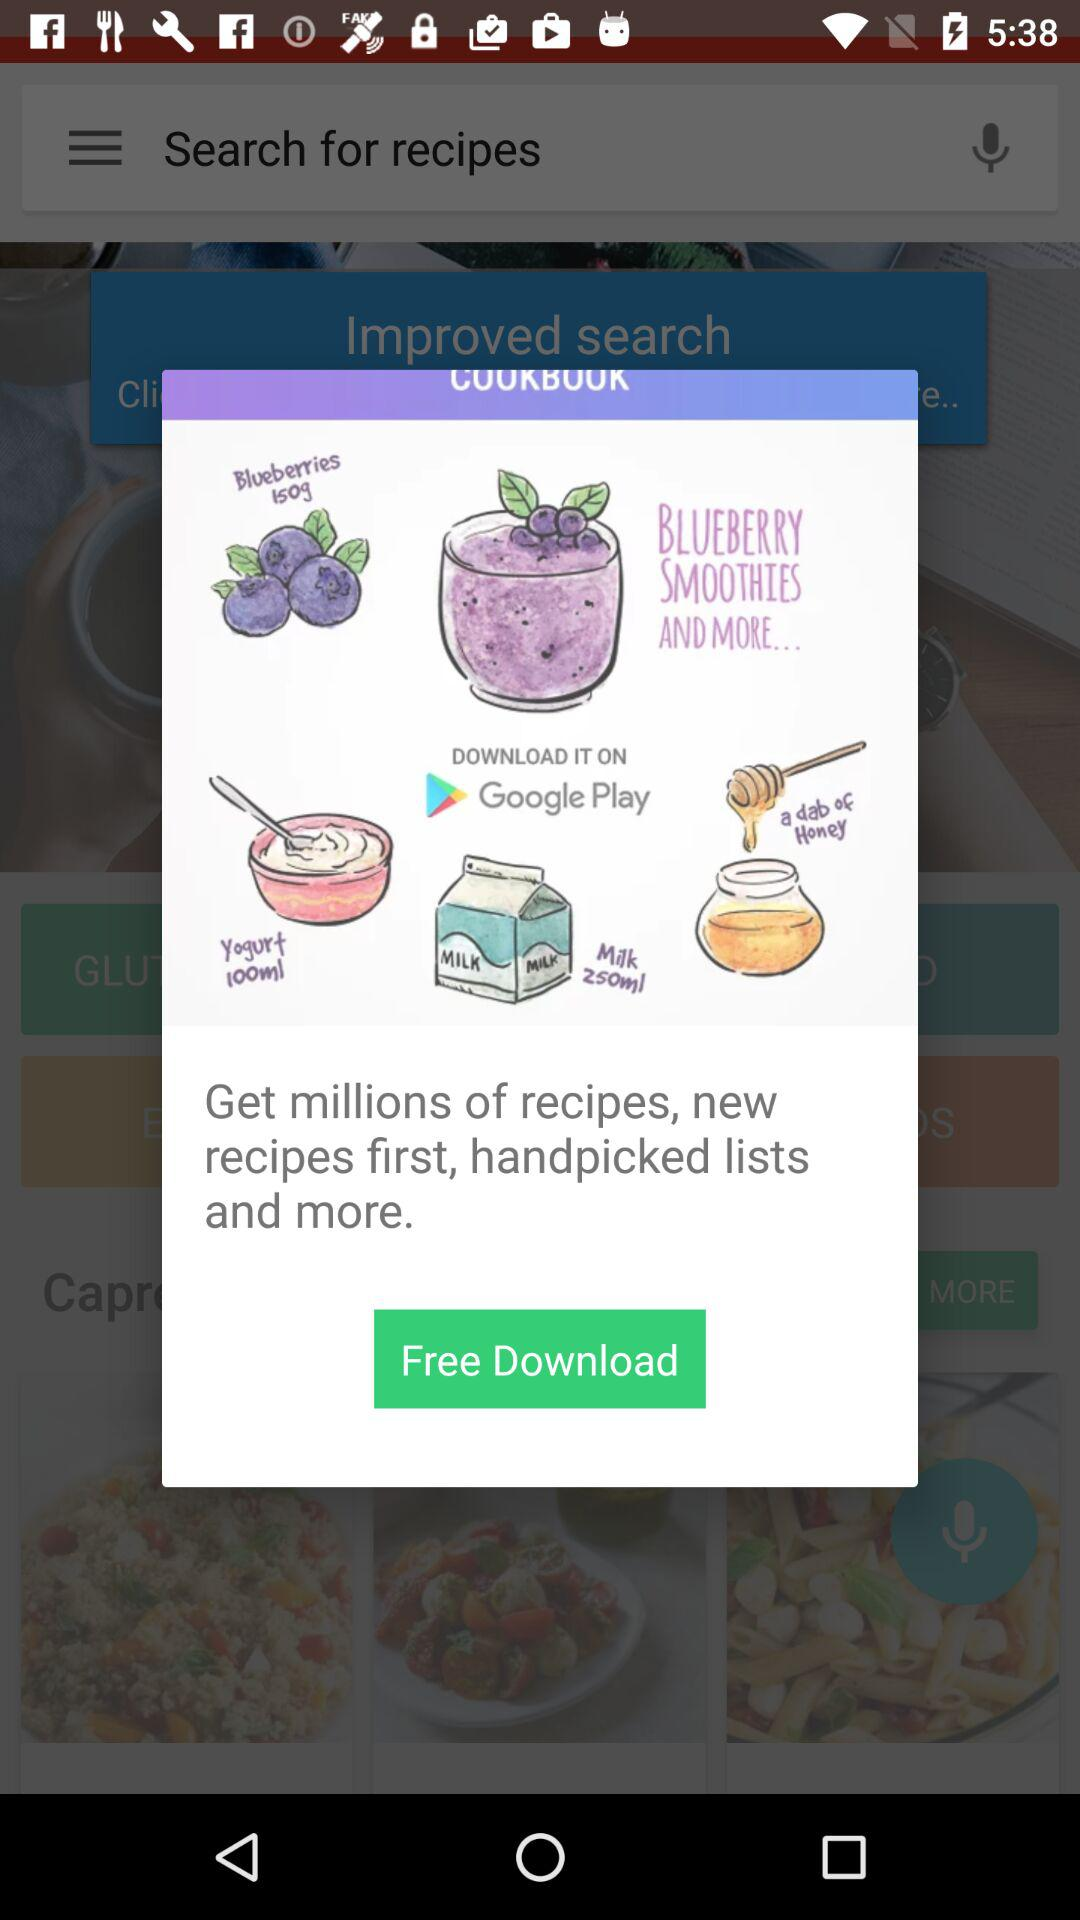From which platform can we download cookbooks?
When the provided information is insufficient, respond with <no answer>. <no answer> 